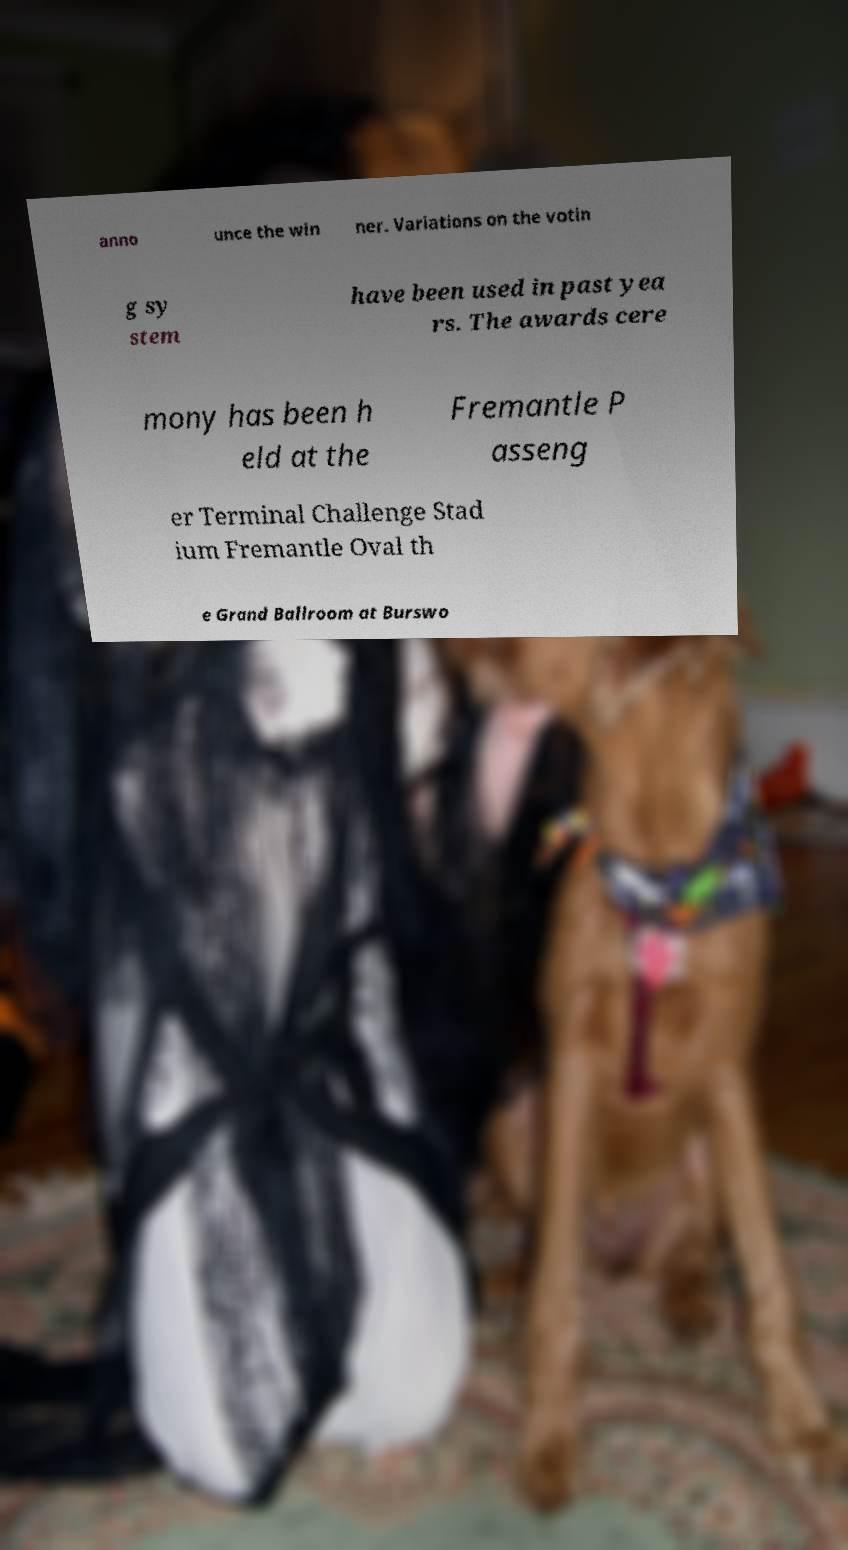Please read and relay the text visible in this image. What does it say? anno unce the win ner. Variations on the votin g sy stem have been used in past yea rs. The awards cere mony has been h eld at the Fremantle P asseng er Terminal Challenge Stad ium Fremantle Oval th e Grand Ballroom at Burswo 